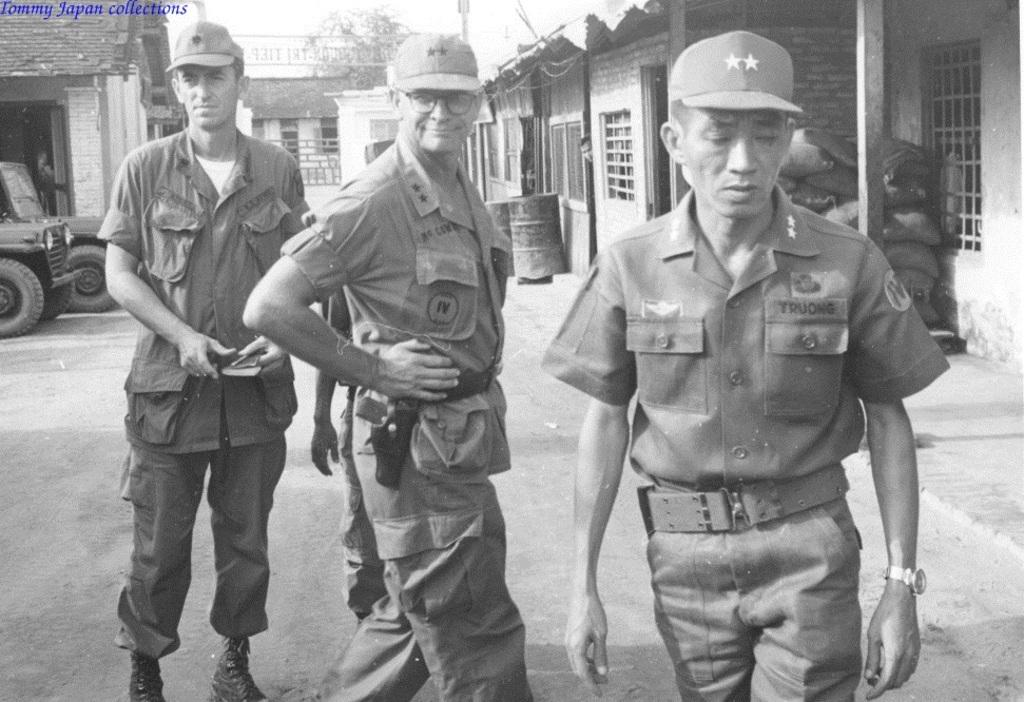How many men are in the foreground of the image? There are three men in the foreground of the image. What are the men doing in the image? The men are walking on the road. What can be seen in the background of the image? There are houses, vehicles, drums, a pole, and gunny bags visible in the background of the image. What type of music can be heard coming from the carriage in the image? There is no carriage present in the image, so it's not possible to determine what, if any, music might be heard. 